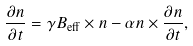<formula> <loc_0><loc_0><loc_500><loc_500>\frac { \partial n } { \partial t } = \gamma B _ { \text {eff} } \times n - \alpha n \times \frac { \partial n } { \partial t } ,</formula> 